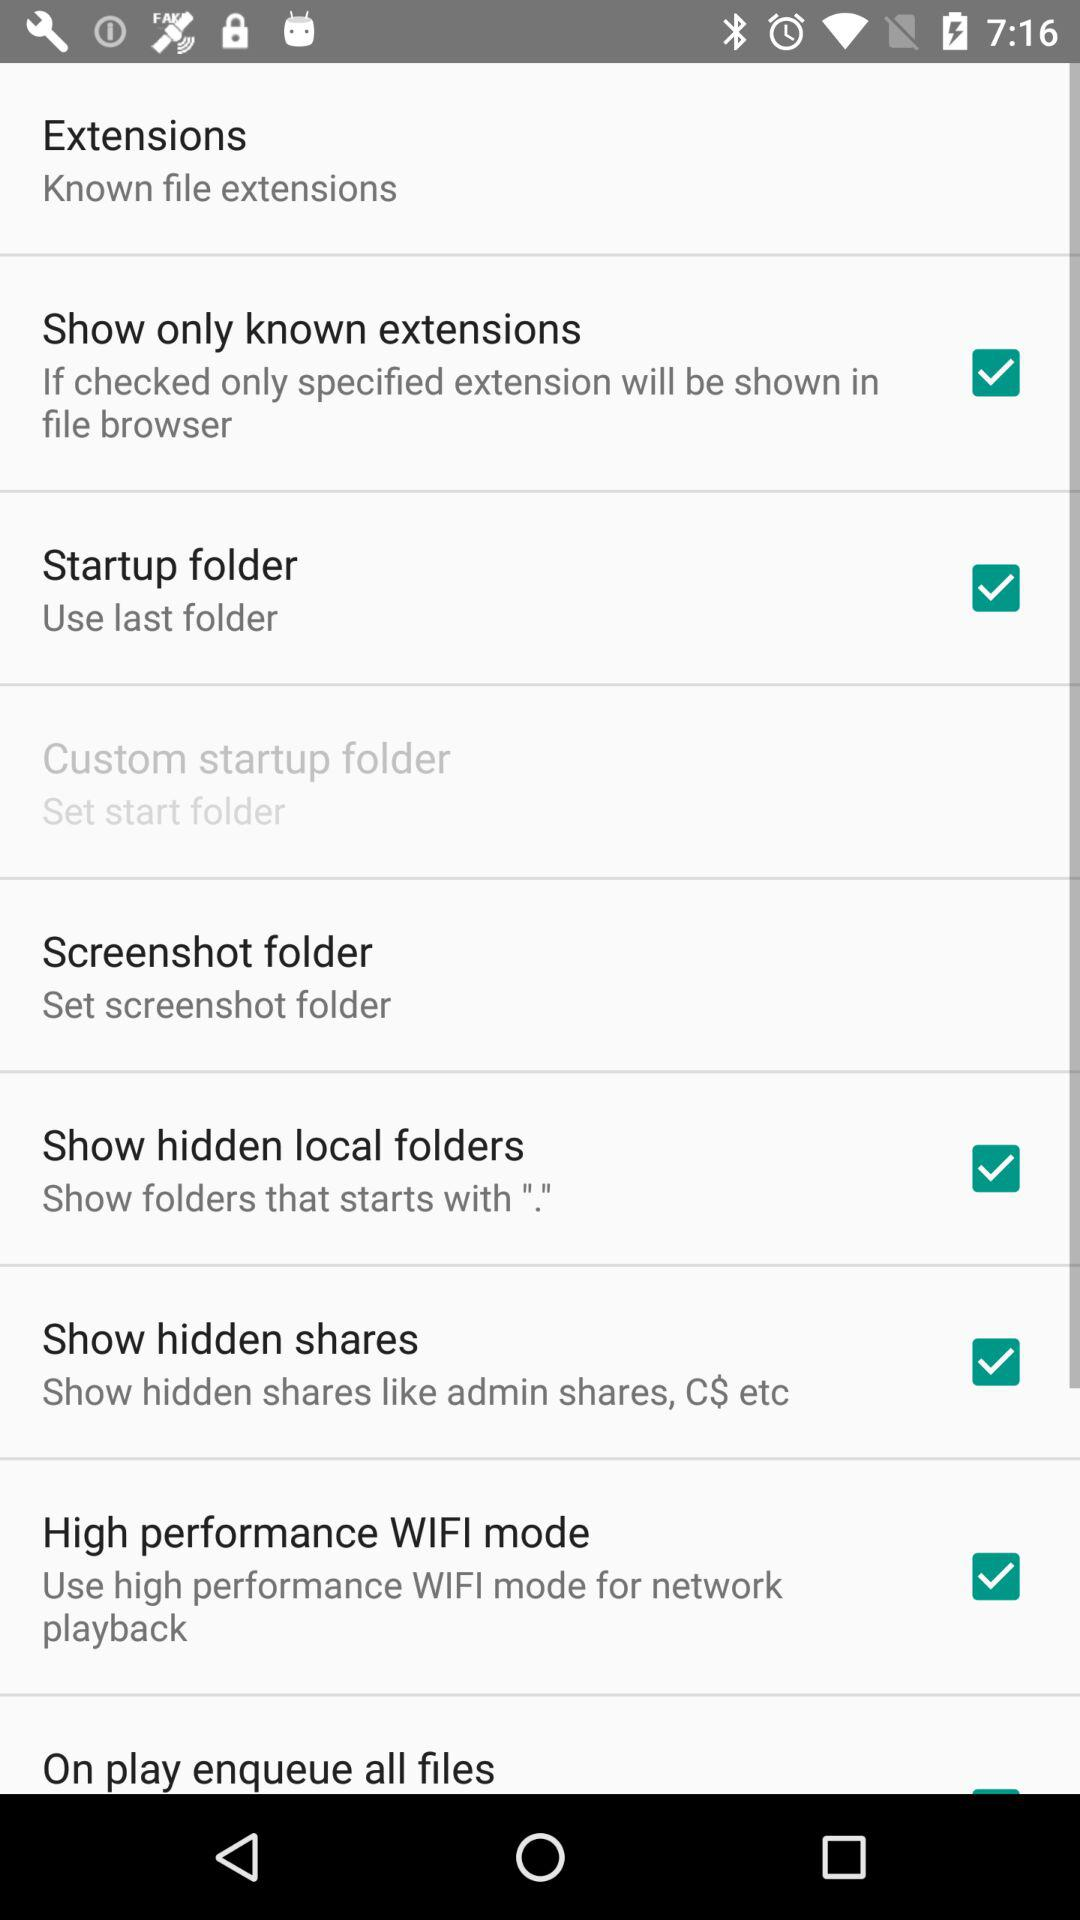Which option is checked? The checked options are "Show only known extensions", "Startup folder", "Show hidden local folders", "Show hidden shares" and "High performance WIFI mode". 